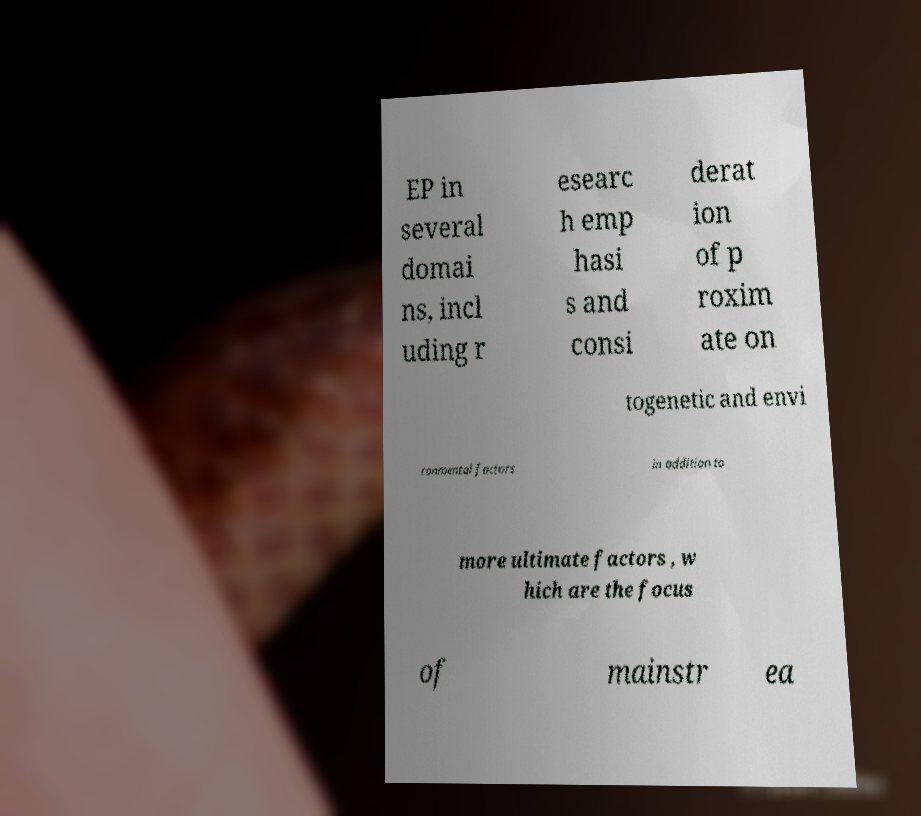Please identify and transcribe the text found in this image. EP in several domai ns, incl uding r esearc h emp hasi s and consi derat ion of p roxim ate on togenetic and envi ronmental factors in addition to more ultimate factors , w hich are the focus of mainstr ea 